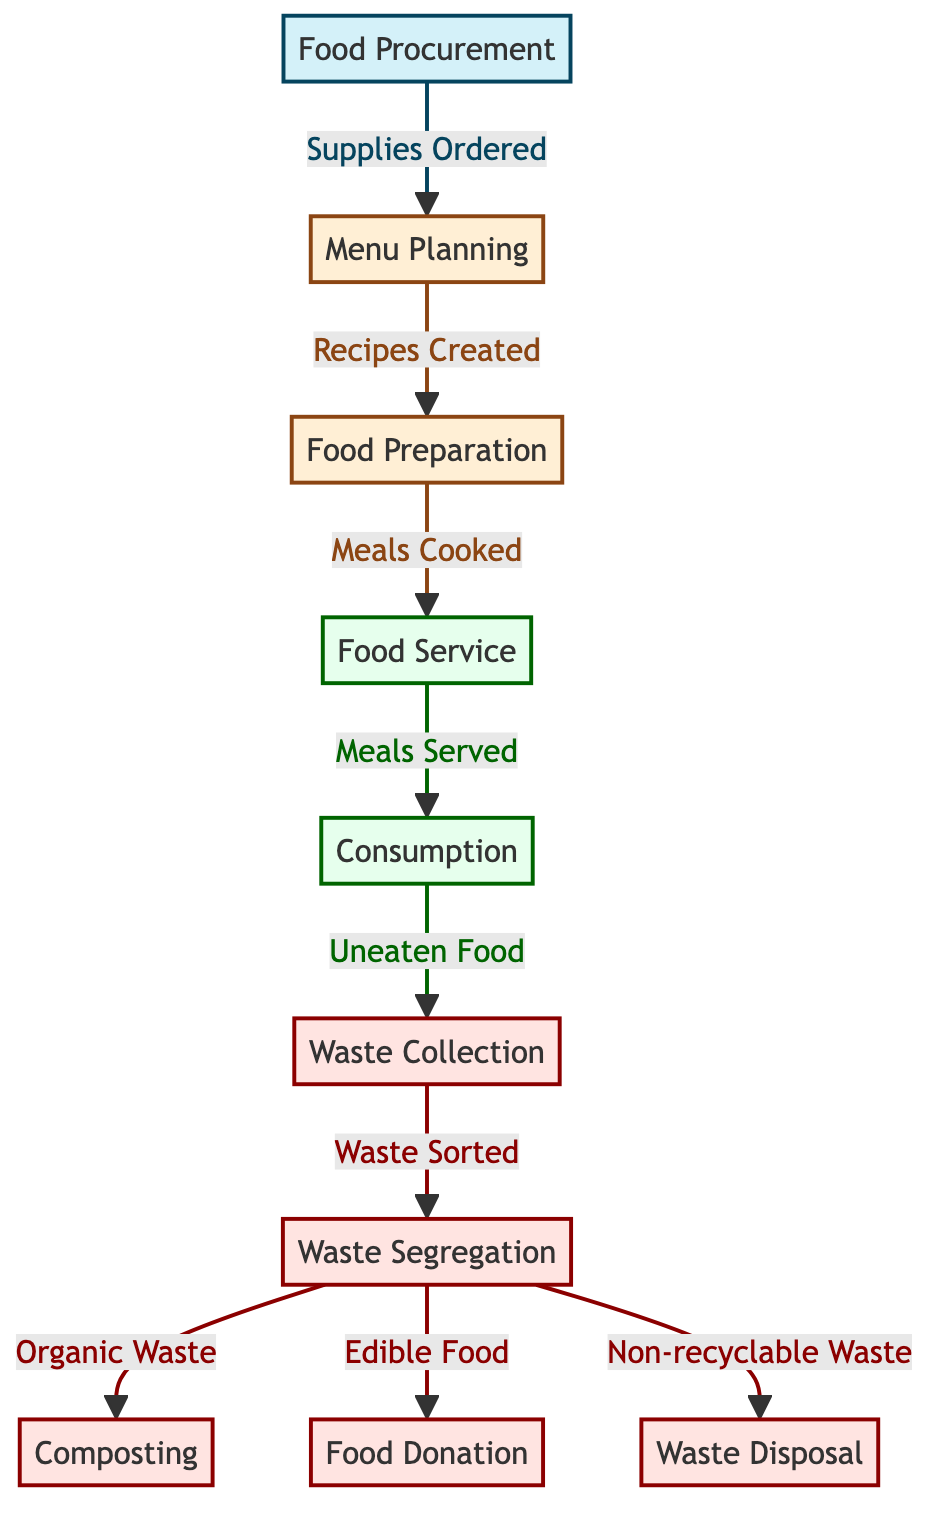What is the first step in the food chain? The first step is 'Food Procurement', as indicated by the starting node of the diagram.
Answer: Food Procurement How many nodes represent waste management? The waste management process includes the nodes 'Waste Collection', 'Waste Segregation', 'Composting', 'Food Donation', and 'Waste Disposal', counting to a total of five nodes.
Answer: 5 What node follows 'Food Service'? 'Consumption' directly follows 'Food Service' according to the directional flow indicated in the diagram.
Answer: Consumption Which node indicates the process of handling organic waste? The node 'Composting' specifically represents the process of handling organic waste as depicted in the diagram.
Answer: Composting What type of waste is handled at the 'Waste Segregation' node? The 'Waste Segregation' node handles organic waste, edible food, and non-recyclable waste as described in the connections of the diagram.
Answer: Organic Waste, Edible Food, Non-recyclable Waste What relationship exists between 'Menu Planning' and 'Food Preparation'? 'Menu Planning' is directly connected to 'Food Preparation' as the output of the menu planning process leads to the creation of recipes for food preparation.
Answer: Supplies Ordered How many edges connect 'Food Preparation' to other nodes? Three edges connect 'Food Preparation' to subsequent nodes: 'Food Service', indicating the flow of meals cooked to prepared meals served.
Answer: 3 Which node is responsible for unused food after meals are served? The 'Uneaten Food' node, which deems the leftover food from the 'Consumption' node, represents the unused food after meals are served.
Answer: Uneaten Food How does 'Food Donation' relate to 'Waste Segregation'? 'Food Donation' is an output of 'Waste Segregation', meaning that edible food identified during segregation is designated for donation instead of disposal.
Answer: Output of Waste Segregation 